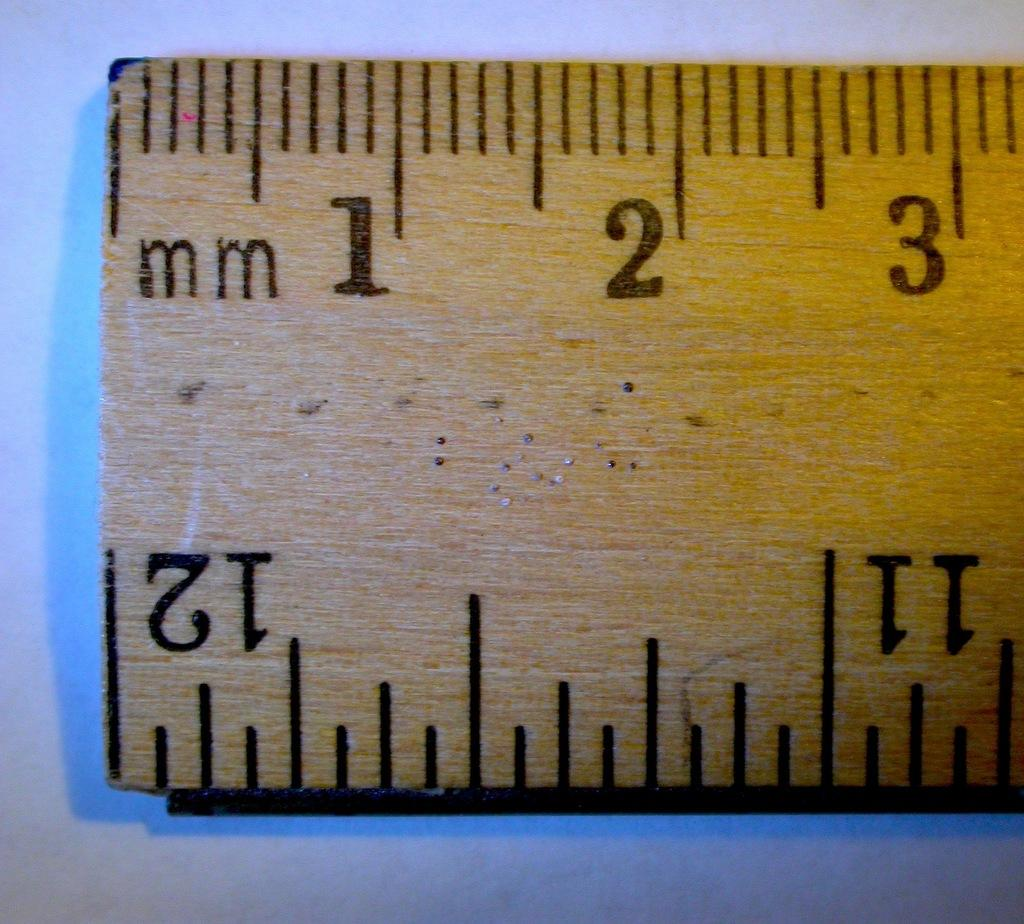<image>
Give a short and clear explanation of the subsequent image. The edge of a ruler is shown and shows the measurements for millimeters, beginning with 1, 2, and 3. 